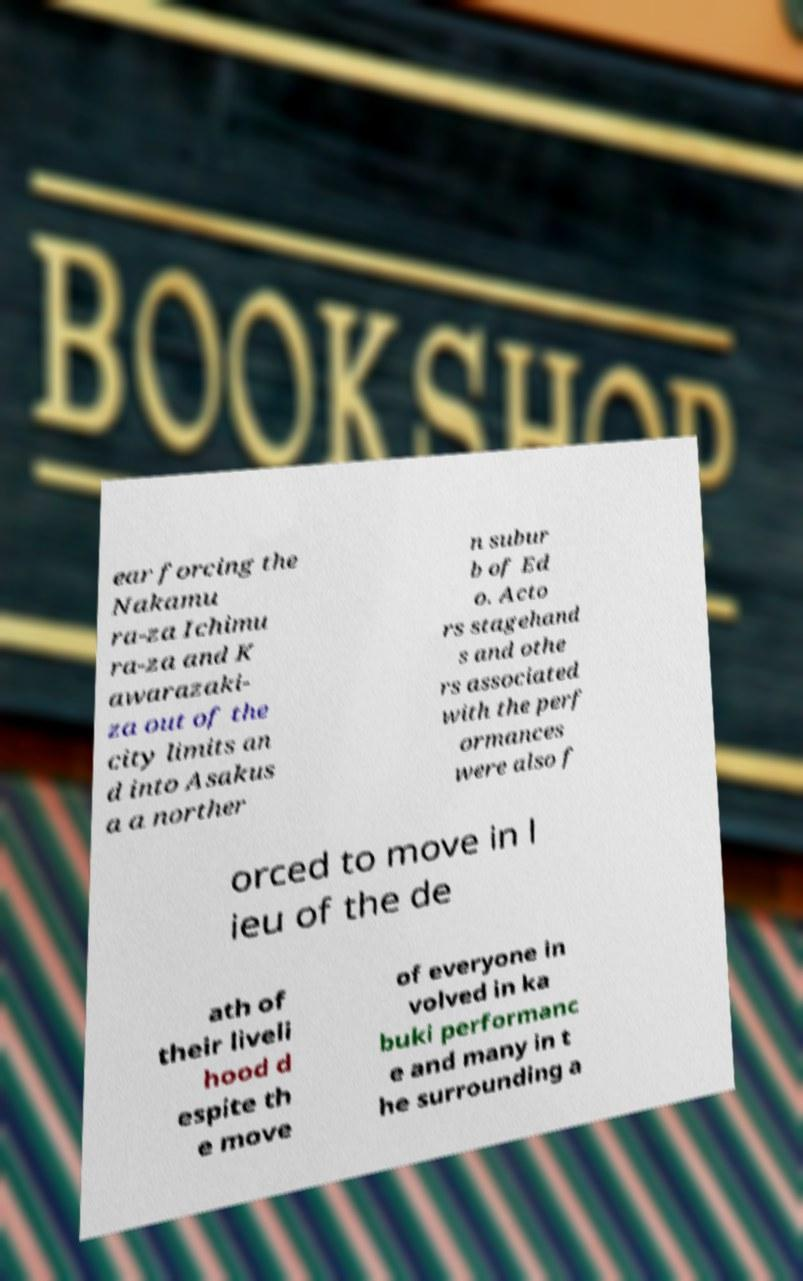Could you extract and type out the text from this image? ear forcing the Nakamu ra-za Ichimu ra-za and K awarazaki- za out of the city limits an d into Asakus a a norther n subur b of Ed o. Acto rs stagehand s and othe rs associated with the perf ormances were also f orced to move in l ieu of the de ath of their liveli hood d espite th e move of everyone in volved in ka buki performanc e and many in t he surrounding a 